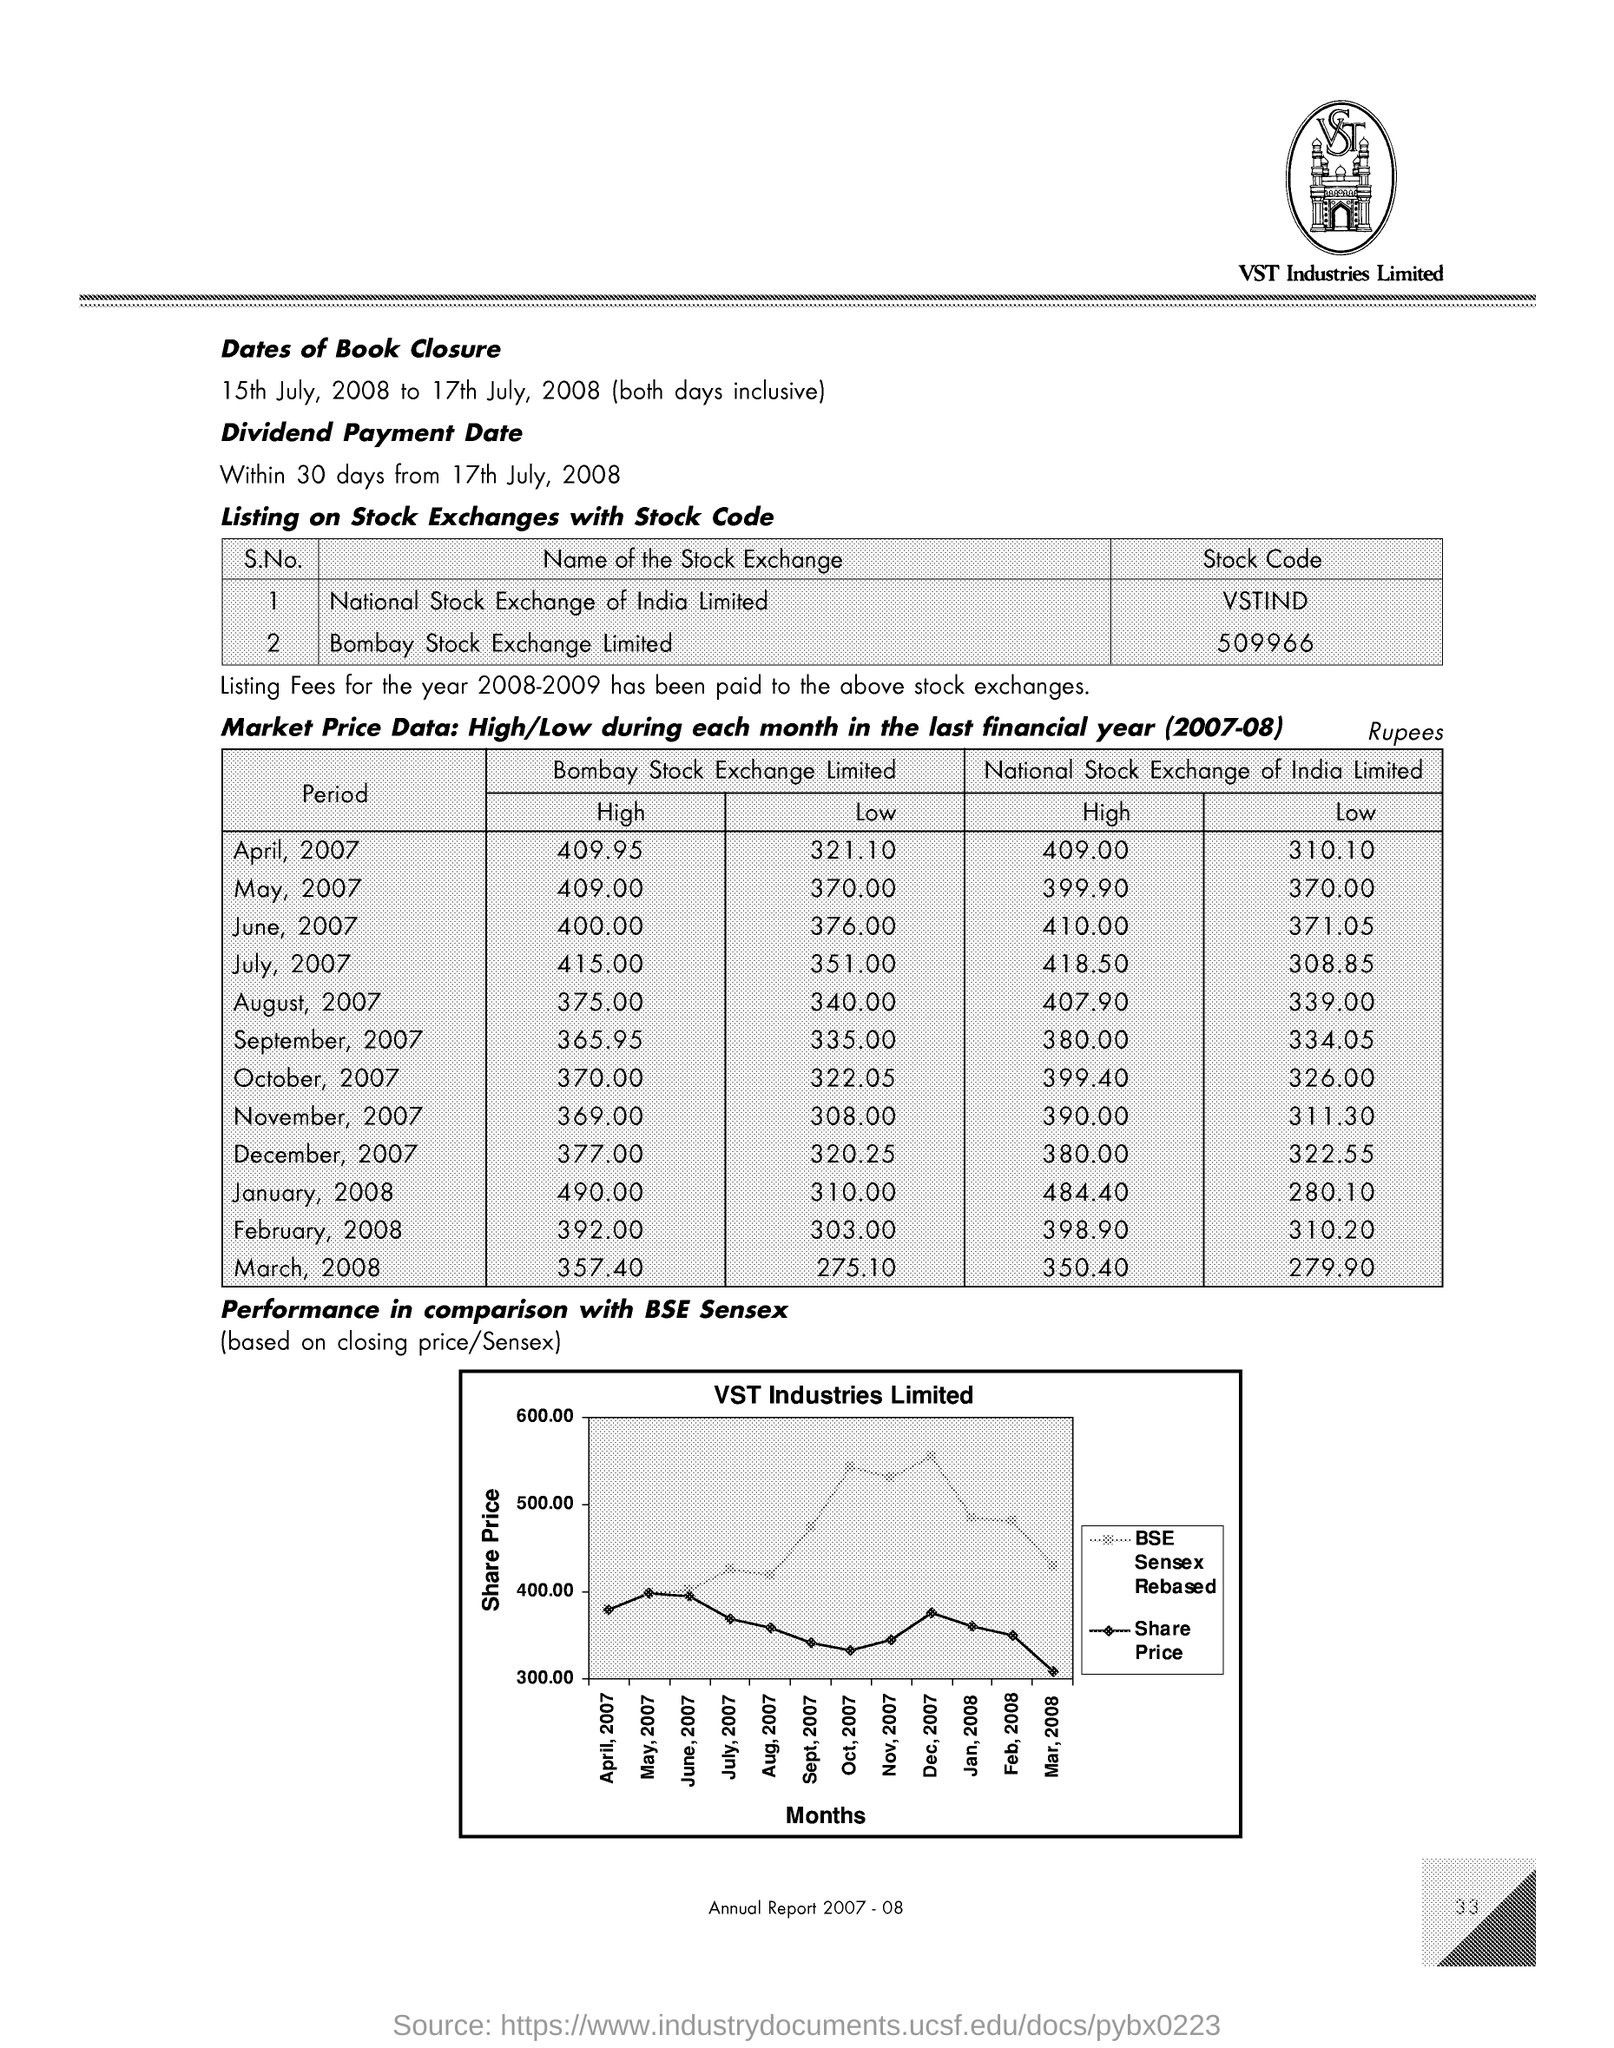What is the  stock code for Bombay Stock Exchange limited ?
Your response must be concise. 509966. What is the Dividend Payment Date ?
Ensure brevity in your answer.  Within 30 days from 17th July, 2008. What is the stock code for National Stock Exchange of India Limited ?
Provide a succinct answer. VSTIND. What is the smallest Low amount of National Stock Exchange of India Limited ?
Keep it short and to the point. 279.90. 